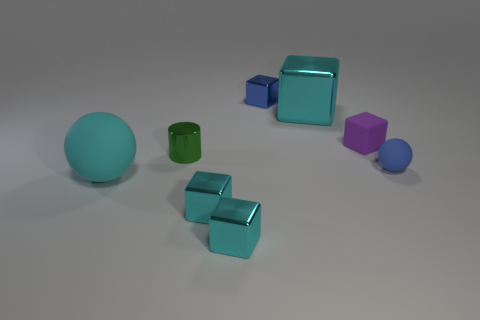Do the purple cube and the cyan block that is behind the tiny cylinder have the same size?
Give a very brief answer. No. There is a rubber sphere to the right of the cube behind the cyan metal object that is behind the large rubber object; what is its color?
Keep it short and to the point. Blue. The big sphere has what color?
Give a very brief answer. Cyan. Are there more things that are on the right side of the large block than cyan metallic cubes that are right of the small purple rubber block?
Your response must be concise. Yes. Does the large cyan matte object have the same shape as the cyan thing behind the small matte block?
Keep it short and to the point. No. There is a ball in front of the blue matte sphere; does it have the same size as the cyan cube behind the tiny blue ball?
Give a very brief answer. Yes. Are there any small shiny blocks in front of the large thing that is behind the blue thing that is in front of the blue cube?
Ensure brevity in your answer.  Yes. Are there fewer big cyan shiny cubes that are to the left of the cyan rubber ball than cyan cubes that are behind the tiny matte ball?
Keep it short and to the point. Yes. There is a tiny blue thing that is made of the same material as the green thing; what is its shape?
Give a very brief answer. Cube. There is a cyan metal cube that is behind the big thing on the left side of the cyan thing behind the large sphere; how big is it?
Provide a succinct answer. Large. 